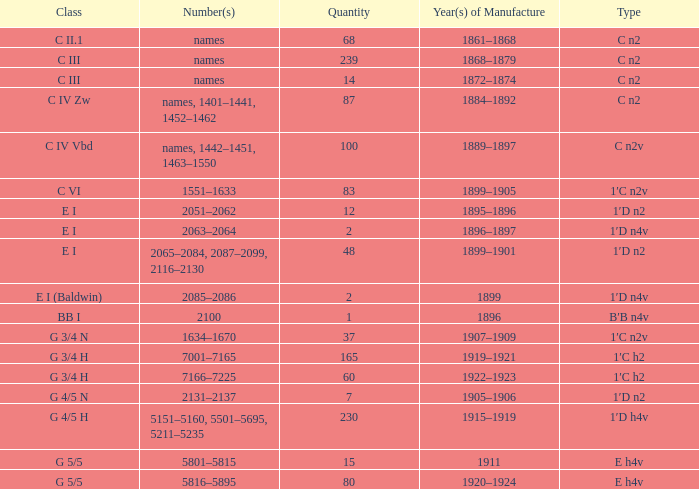What amount features a category of e h4v, and a production year(s) of 1920-1924? 80.0. 